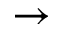<formula> <loc_0><loc_0><loc_500><loc_500>\rightarrow</formula> 